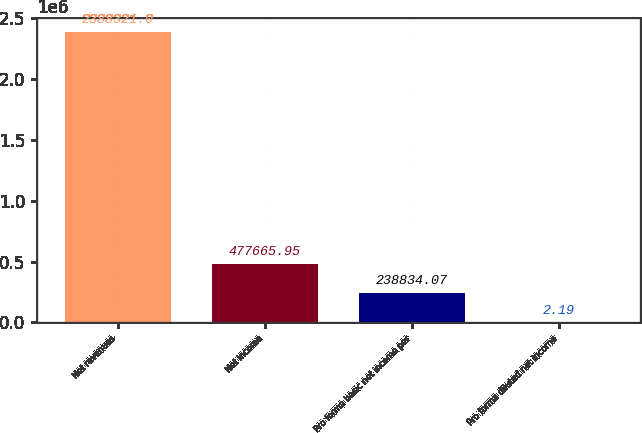<chart> <loc_0><loc_0><loc_500><loc_500><bar_chart><fcel>Net revenues<fcel>Net income<fcel>Pro forma basic net income per<fcel>Pro forma diluted net income<nl><fcel>2.38832e+06<fcel>477666<fcel>238834<fcel>2.19<nl></chart> 